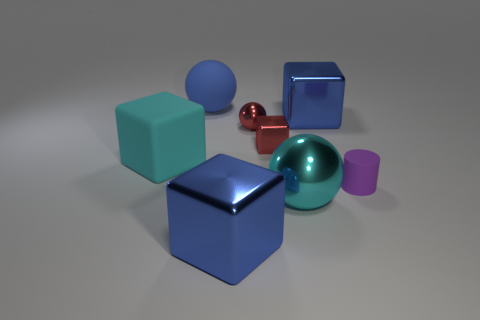Which shapes in the image are metallic? The small red sphere and the smaller blue cube appear to have a metallic finish due to their reflective surfaces. 